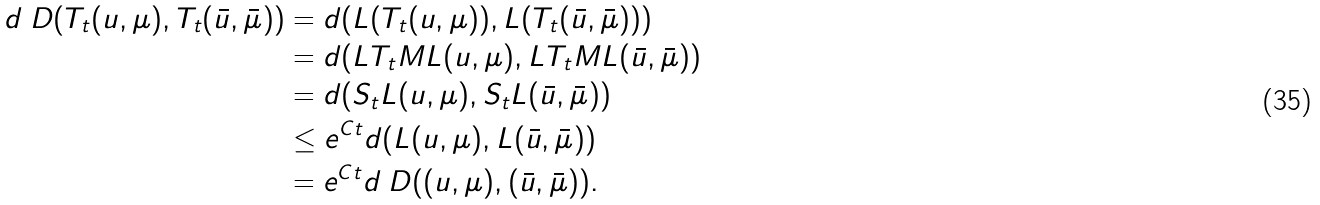Convert formula to latex. <formula><loc_0><loc_0><loc_500><loc_500>d _ { \ } D ( T _ { t } ( u , \mu ) , T _ { t } ( \bar { u } , \bar { \mu } ) ) & = d ( L ( T _ { t } ( u , \mu ) ) , L ( T _ { t } ( \bar { u } , \bar { \mu } ) ) ) \\ & = d ( L T _ { t } M L ( u , \mu ) , L T _ { t } M L ( \bar { u } , \bar { \mu } ) ) \\ & = d ( S _ { t } L ( u , \mu ) , S _ { t } L ( \bar { u } , \bar { \mu } ) ) \\ & \leq e ^ { C t } d ( L ( u , \mu ) , L ( \bar { u } , \bar { \mu } ) ) \\ & = e ^ { C t } d _ { \ } D ( ( u , \mu ) , ( \bar { u } , \bar { \mu } ) ) .</formula> 